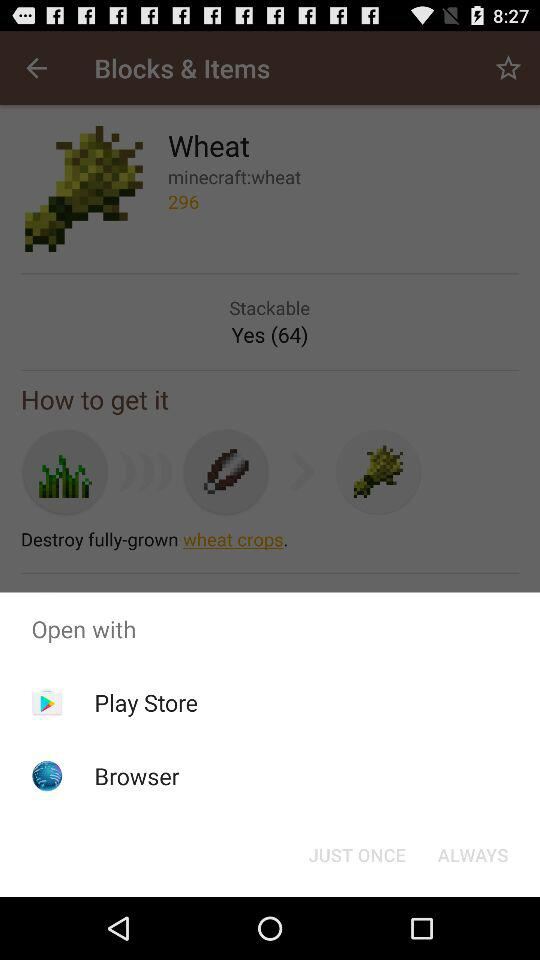How many more items are in the how to get it section than the open with section?
Answer the question using a single word or phrase. 1 